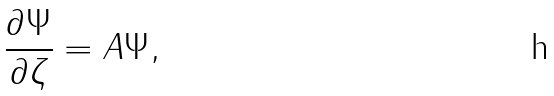<formula> <loc_0><loc_0><loc_500><loc_500>\frac { \partial \Psi } { \partial \zeta } = A \Psi ,</formula> 